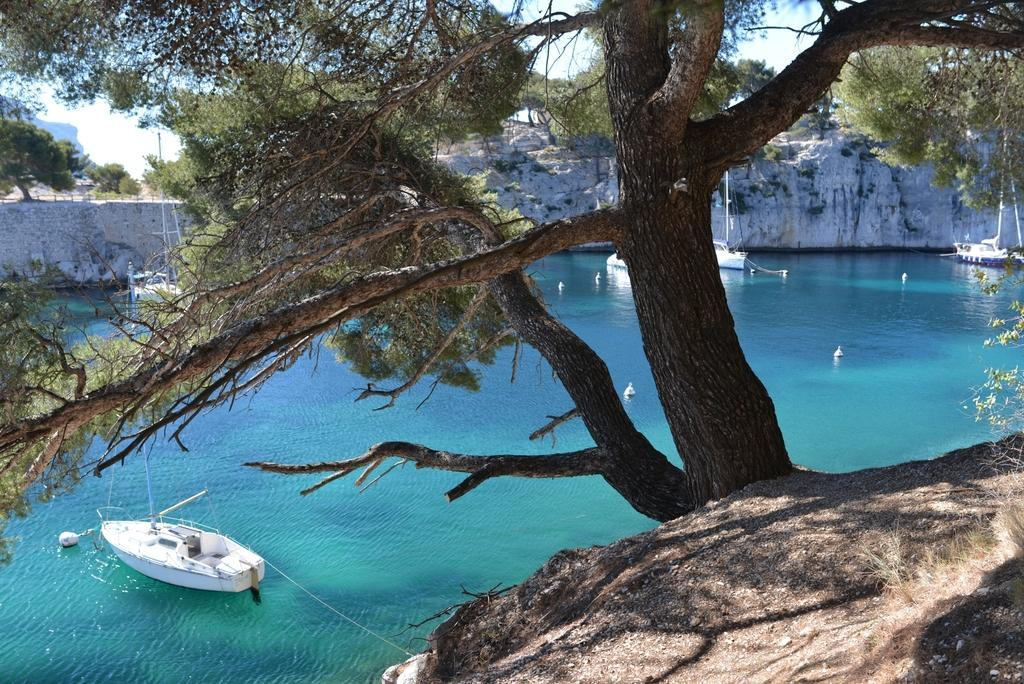What is in the water in the image? There are boats in the water in the image. What type of vegetation can be seen in the image? Trees are visible in the image. What is visible in the background of the image? The sky is visible in the background of the image. What activity is the elbow performing in the image? There is no elbow present in the image, as it features boats in the water and trees in the background. 